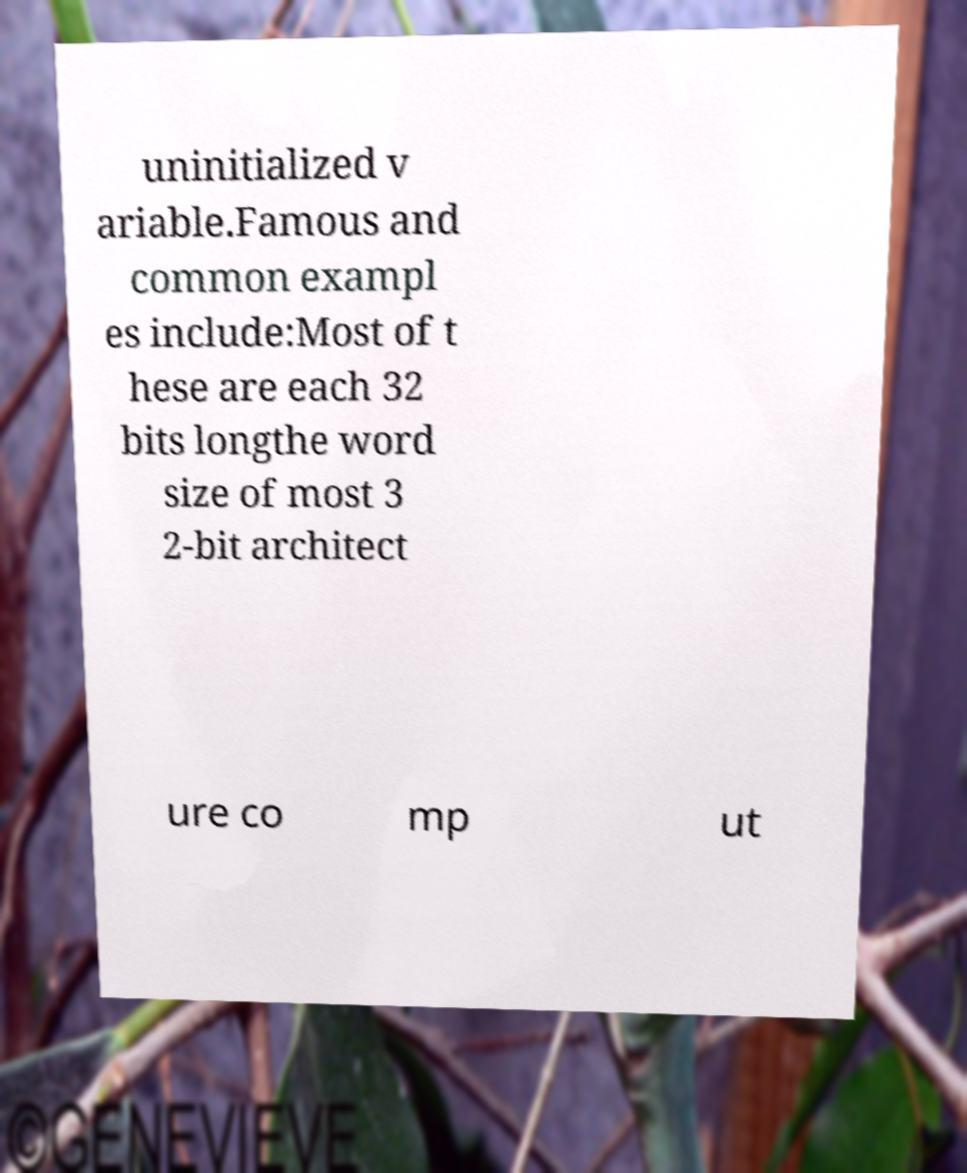Please read and relay the text visible in this image. What does it say? uninitialized v ariable.Famous and common exampl es include:Most of t hese are each 32 bits longthe word size of most 3 2-bit architect ure co mp ut 